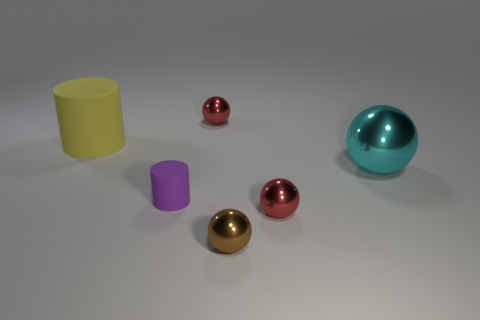Add 1 big cyan matte objects. How many objects exist? 7 Subtract all spheres. How many objects are left? 2 Add 6 blue rubber balls. How many blue rubber balls exist? 6 Subtract 0 green balls. How many objects are left? 6 Subtract all cyan metal things. Subtract all small brown objects. How many objects are left? 4 Add 2 big yellow rubber cylinders. How many big yellow rubber cylinders are left? 3 